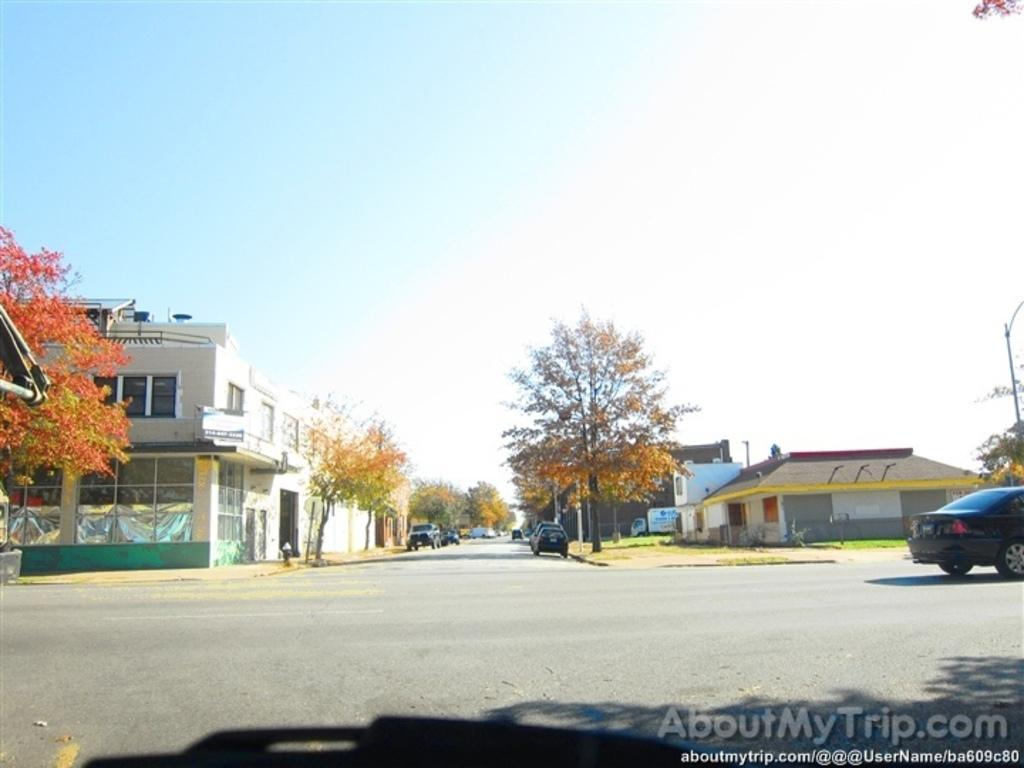What types of structures are visible in the image? There are buildings and houses in the image. What else can be seen in the image besides structures? There are trees and cars visible in the image. Are there any vertical objects in the image? Yes, there are poles in the image. What type of plantation can be seen in the image? There is no plantation present in the image. Is there a whip visible in the image? No, there is no whip present in the image. 